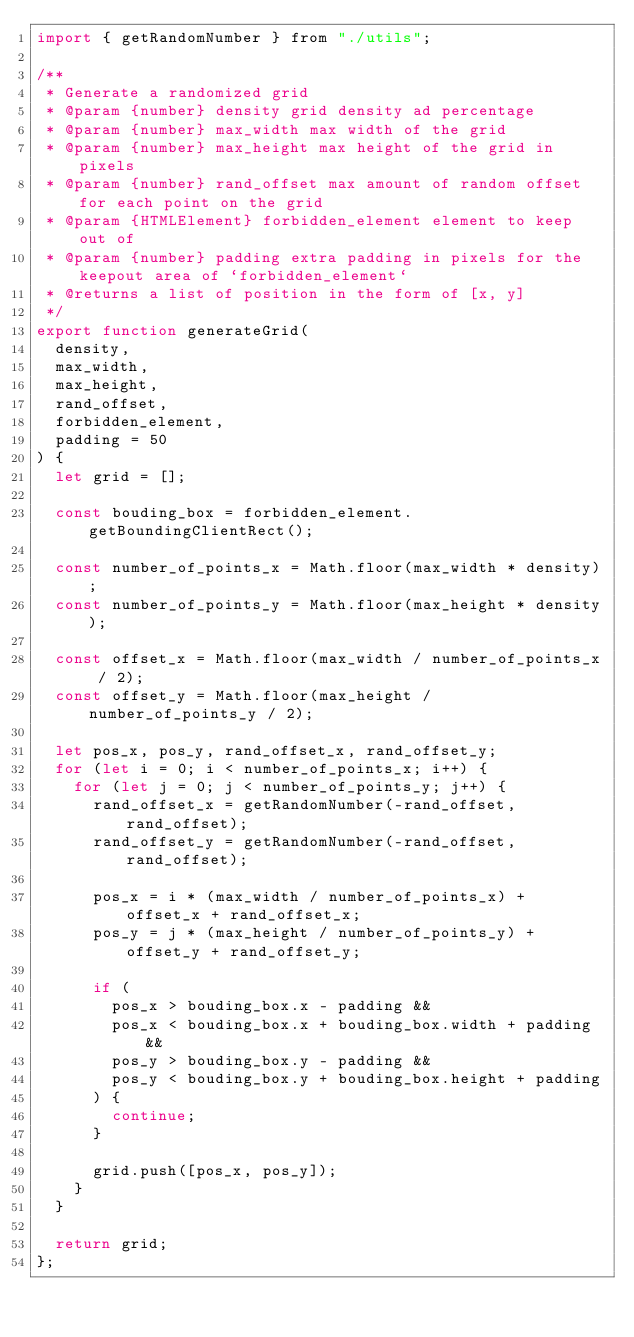Convert code to text. <code><loc_0><loc_0><loc_500><loc_500><_JavaScript_>import { getRandomNumber } from "./utils";

/**
 * Generate a randomized grid
 * @param {number} density grid density ad percentage
 * @param {number} max_width max width of the grid
 * @param {number} max_height max height of the grid in pixels
 * @param {number} rand_offset max amount of random offset for each point on the grid
 * @param {HTMLElement} forbidden_element element to keep out of
 * @param {number} padding extra padding in pixels for the keepout area of `forbidden_element`
 * @returns a list of position in the form of [x, y]
 */
export function generateGrid(
  density,
  max_width,
  max_height,
  rand_offset,
  forbidden_element,
  padding = 50
) {
  let grid = [];

  const bouding_box = forbidden_element.getBoundingClientRect();

  const number_of_points_x = Math.floor(max_width * density);
  const number_of_points_y = Math.floor(max_height * density);

  const offset_x = Math.floor(max_width / number_of_points_x / 2);
  const offset_y = Math.floor(max_height / number_of_points_y / 2);

  let pos_x, pos_y, rand_offset_x, rand_offset_y;
  for (let i = 0; i < number_of_points_x; i++) {
    for (let j = 0; j < number_of_points_y; j++) {
      rand_offset_x = getRandomNumber(-rand_offset, rand_offset);
      rand_offset_y = getRandomNumber(-rand_offset, rand_offset);

      pos_x = i * (max_width / number_of_points_x) + offset_x + rand_offset_x;
      pos_y = j * (max_height / number_of_points_y) + offset_y + rand_offset_y;

      if (
        pos_x > bouding_box.x - padding &&
        pos_x < bouding_box.x + bouding_box.width + padding &&
        pos_y > bouding_box.y - padding &&
        pos_y < bouding_box.y + bouding_box.height + padding
      ) {
        continue;
      }

      grid.push([pos_x, pos_y]);
    }
  }

  return grid;
};</code> 